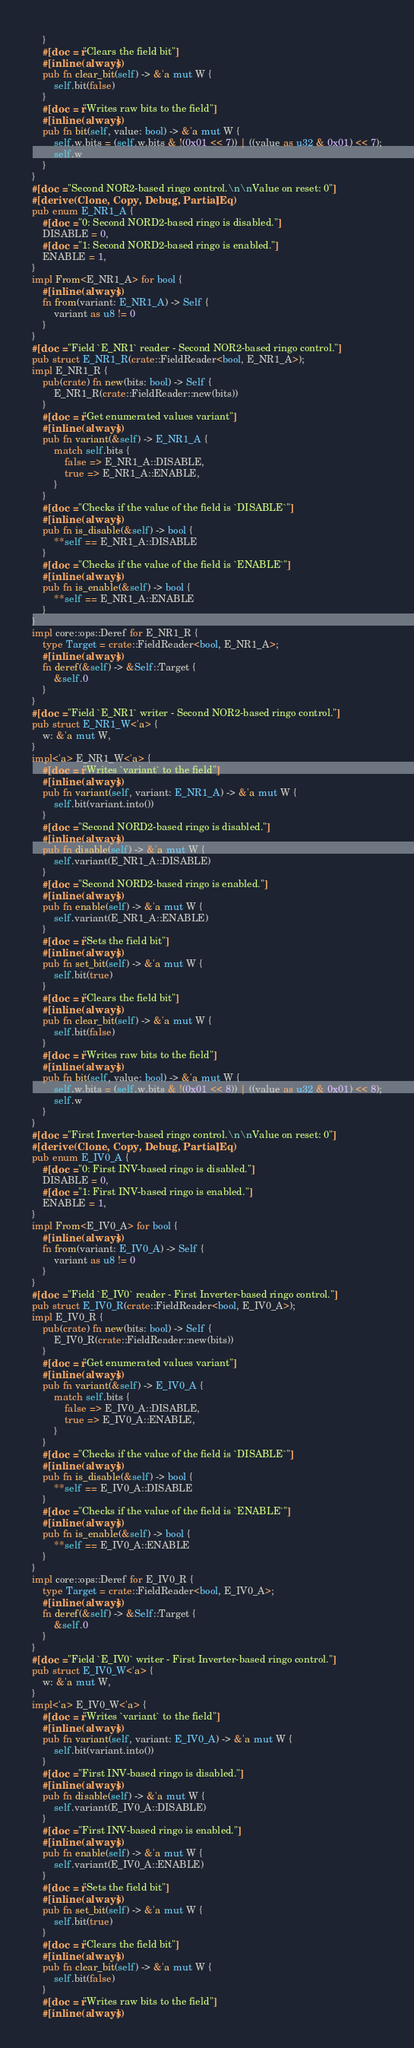Convert code to text. <code><loc_0><loc_0><loc_500><loc_500><_Rust_>    }
    #[doc = r"Clears the field bit"]
    #[inline(always)]
    pub fn clear_bit(self) -> &'a mut W {
        self.bit(false)
    }
    #[doc = r"Writes raw bits to the field"]
    #[inline(always)]
    pub fn bit(self, value: bool) -> &'a mut W {
        self.w.bits = (self.w.bits & !(0x01 << 7)) | ((value as u32 & 0x01) << 7);
        self.w
    }
}
#[doc = "Second NOR2-based ringo control.\n\nValue on reset: 0"]
#[derive(Clone, Copy, Debug, PartialEq)]
pub enum E_NR1_A {
    #[doc = "0: Second NORD2-based ringo is disabled."]
    DISABLE = 0,
    #[doc = "1: Second NORD2-based ringo is enabled."]
    ENABLE = 1,
}
impl From<E_NR1_A> for bool {
    #[inline(always)]
    fn from(variant: E_NR1_A) -> Self {
        variant as u8 != 0
    }
}
#[doc = "Field `E_NR1` reader - Second NOR2-based ringo control."]
pub struct E_NR1_R(crate::FieldReader<bool, E_NR1_A>);
impl E_NR1_R {
    pub(crate) fn new(bits: bool) -> Self {
        E_NR1_R(crate::FieldReader::new(bits))
    }
    #[doc = r"Get enumerated values variant"]
    #[inline(always)]
    pub fn variant(&self) -> E_NR1_A {
        match self.bits {
            false => E_NR1_A::DISABLE,
            true => E_NR1_A::ENABLE,
        }
    }
    #[doc = "Checks if the value of the field is `DISABLE`"]
    #[inline(always)]
    pub fn is_disable(&self) -> bool {
        **self == E_NR1_A::DISABLE
    }
    #[doc = "Checks if the value of the field is `ENABLE`"]
    #[inline(always)]
    pub fn is_enable(&self) -> bool {
        **self == E_NR1_A::ENABLE
    }
}
impl core::ops::Deref for E_NR1_R {
    type Target = crate::FieldReader<bool, E_NR1_A>;
    #[inline(always)]
    fn deref(&self) -> &Self::Target {
        &self.0
    }
}
#[doc = "Field `E_NR1` writer - Second NOR2-based ringo control."]
pub struct E_NR1_W<'a> {
    w: &'a mut W,
}
impl<'a> E_NR1_W<'a> {
    #[doc = r"Writes `variant` to the field"]
    #[inline(always)]
    pub fn variant(self, variant: E_NR1_A) -> &'a mut W {
        self.bit(variant.into())
    }
    #[doc = "Second NORD2-based ringo is disabled."]
    #[inline(always)]
    pub fn disable(self) -> &'a mut W {
        self.variant(E_NR1_A::DISABLE)
    }
    #[doc = "Second NORD2-based ringo is enabled."]
    #[inline(always)]
    pub fn enable(self) -> &'a mut W {
        self.variant(E_NR1_A::ENABLE)
    }
    #[doc = r"Sets the field bit"]
    #[inline(always)]
    pub fn set_bit(self) -> &'a mut W {
        self.bit(true)
    }
    #[doc = r"Clears the field bit"]
    #[inline(always)]
    pub fn clear_bit(self) -> &'a mut W {
        self.bit(false)
    }
    #[doc = r"Writes raw bits to the field"]
    #[inline(always)]
    pub fn bit(self, value: bool) -> &'a mut W {
        self.w.bits = (self.w.bits & !(0x01 << 8)) | ((value as u32 & 0x01) << 8);
        self.w
    }
}
#[doc = "First Inverter-based ringo control.\n\nValue on reset: 0"]
#[derive(Clone, Copy, Debug, PartialEq)]
pub enum E_IV0_A {
    #[doc = "0: First INV-based ringo is disabled."]
    DISABLE = 0,
    #[doc = "1: First INV-based ringo is enabled."]
    ENABLE = 1,
}
impl From<E_IV0_A> for bool {
    #[inline(always)]
    fn from(variant: E_IV0_A) -> Self {
        variant as u8 != 0
    }
}
#[doc = "Field `E_IV0` reader - First Inverter-based ringo control."]
pub struct E_IV0_R(crate::FieldReader<bool, E_IV0_A>);
impl E_IV0_R {
    pub(crate) fn new(bits: bool) -> Self {
        E_IV0_R(crate::FieldReader::new(bits))
    }
    #[doc = r"Get enumerated values variant"]
    #[inline(always)]
    pub fn variant(&self) -> E_IV0_A {
        match self.bits {
            false => E_IV0_A::DISABLE,
            true => E_IV0_A::ENABLE,
        }
    }
    #[doc = "Checks if the value of the field is `DISABLE`"]
    #[inline(always)]
    pub fn is_disable(&self) -> bool {
        **self == E_IV0_A::DISABLE
    }
    #[doc = "Checks if the value of the field is `ENABLE`"]
    #[inline(always)]
    pub fn is_enable(&self) -> bool {
        **self == E_IV0_A::ENABLE
    }
}
impl core::ops::Deref for E_IV0_R {
    type Target = crate::FieldReader<bool, E_IV0_A>;
    #[inline(always)]
    fn deref(&self) -> &Self::Target {
        &self.0
    }
}
#[doc = "Field `E_IV0` writer - First Inverter-based ringo control."]
pub struct E_IV0_W<'a> {
    w: &'a mut W,
}
impl<'a> E_IV0_W<'a> {
    #[doc = r"Writes `variant` to the field"]
    #[inline(always)]
    pub fn variant(self, variant: E_IV0_A) -> &'a mut W {
        self.bit(variant.into())
    }
    #[doc = "First INV-based ringo is disabled."]
    #[inline(always)]
    pub fn disable(self) -> &'a mut W {
        self.variant(E_IV0_A::DISABLE)
    }
    #[doc = "First INV-based ringo is enabled."]
    #[inline(always)]
    pub fn enable(self) -> &'a mut W {
        self.variant(E_IV0_A::ENABLE)
    }
    #[doc = r"Sets the field bit"]
    #[inline(always)]
    pub fn set_bit(self) -> &'a mut W {
        self.bit(true)
    }
    #[doc = r"Clears the field bit"]
    #[inline(always)]
    pub fn clear_bit(self) -> &'a mut W {
        self.bit(false)
    }
    #[doc = r"Writes raw bits to the field"]
    #[inline(always)]</code> 